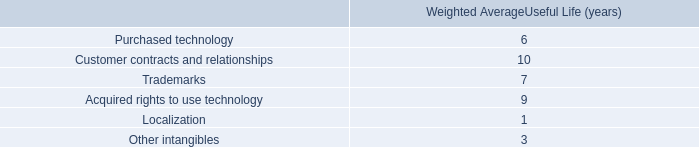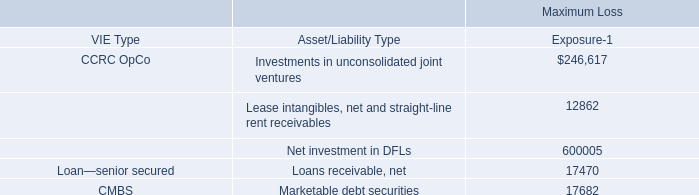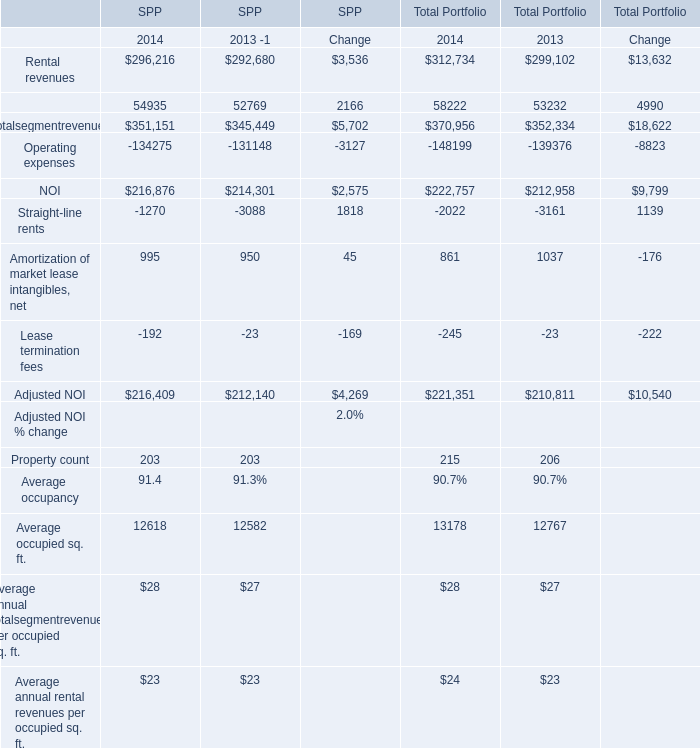What was the total amount of NOI of SPP greater than 50000? 
Computations: (292680 + 52769)
Answer: 345449.0. 